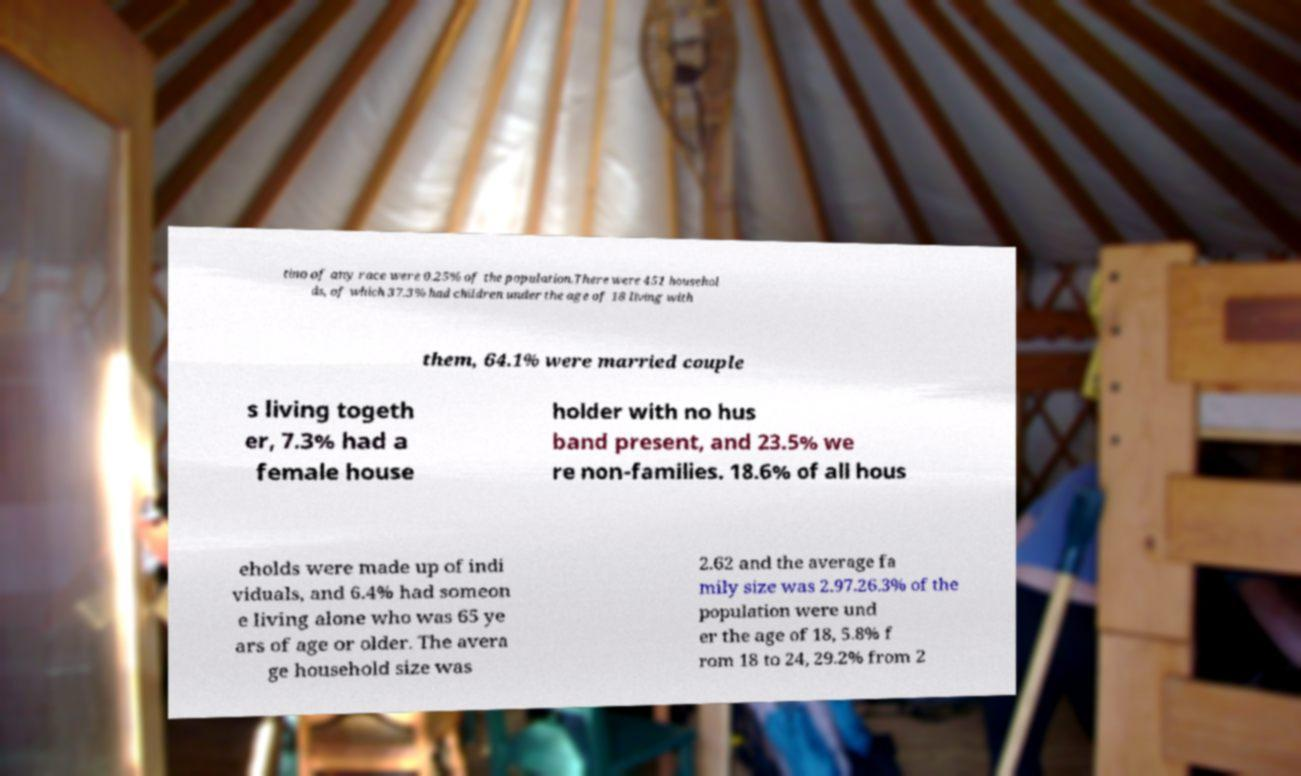For documentation purposes, I need the text within this image transcribed. Could you provide that? tino of any race were 0.25% of the population.There were 451 househol ds, of which 37.3% had children under the age of 18 living with them, 64.1% were married couple s living togeth er, 7.3% had a female house holder with no hus band present, and 23.5% we re non-families. 18.6% of all hous eholds were made up of indi viduals, and 6.4% had someon e living alone who was 65 ye ars of age or older. The avera ge household size was 2.62 and the average fa mily size was 2.97.26.3% of the population were und er the age of 18, 5.8% f rom 18 to 24, 29.2% from 2 